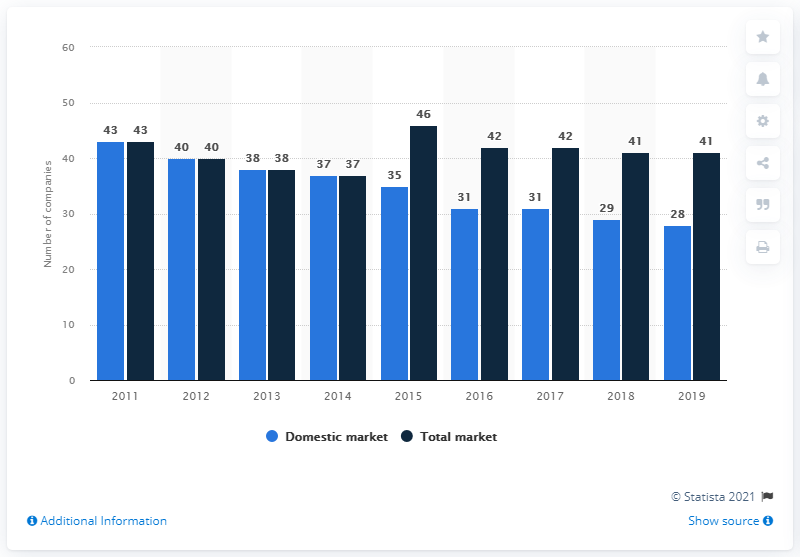Specify some key components in this picture. By the end of 2019, a total of 28 insurance companies were operating on the Romanian domestic insurance market. 